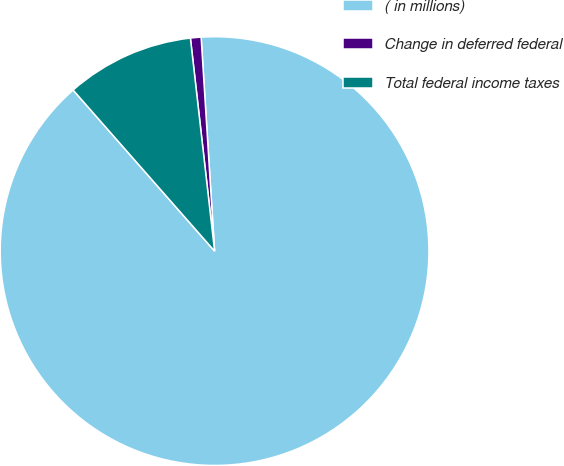Convert chart. <chart><loc_0><loc_0><loc_500><loc_500><pie_chart><fcel>( in millions)<fcel>Change in deferred federal<fcel>Total federal income taxes<nl><fcel>89.52%<fcel>0.8%<fcel>9.67%<nl></chart> 